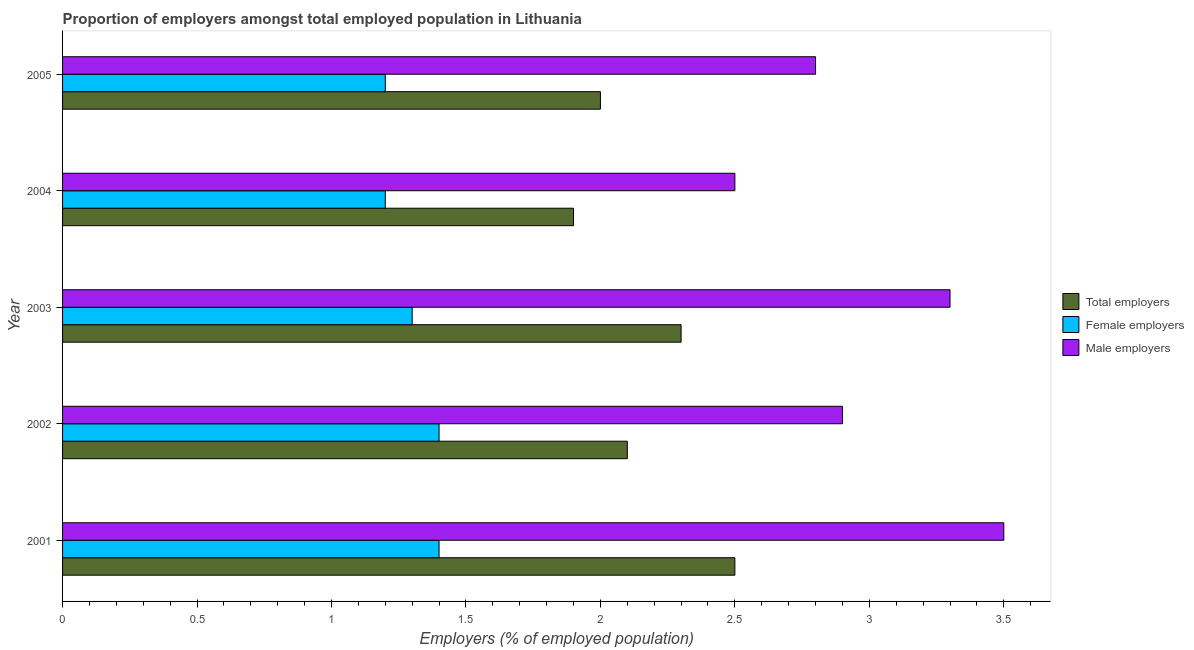How many groups of bars are there?
Offer a terse response. 5. Are the number of bars per tick equal to the number of legend labels?
Keep it short and to the point. Yes. Are the number of bars on each tick of the Y-axis equal?
Ensure brevity in your answer.  Yes. What is the label of the 3rd group of bars from the top?
Ensure brevity in your answer.  2003. In how many cases, is the number of bars for a given year not equal to the number of legend labels?
Make the answer very short. 0. What is the percentage of male employers in 2004?
Offer a terse response. 2.5. Across all years, what is the minimum percentage of total employers?
Make the answer very short. 1.9. In which year was the percentage of total employers minimum?
Give a very brief answer. 2004. What is the total percentage of male employers in the graph?
Your response must be concise. 15. What is the difference between the percentage of male employers in 2002 and the percentage of total employers in 2005?
Your response must be concise. 0.9. What is the ratio of the percentage of male employers in 2001 to that in 2005?
Ensure brevity in your answer.  1.25. Is the percentage of female employers in 2002 less than that in 2003?
Your answer should be very brief. No. Is the difference between the percentage of male employers in 2001 and 2003 greater than the difference between the percentage of total employers in 2001 and 2003?
Give a very brief answer. No. What is the difference between the highest and the second highest percentage of male employers?
Provide a short and direct response. 0.2. In how many years, is the percentage of total employers greater than the average percentage of total employers taken over all years?
Your response must be concise. 2. Is the sum of the percentage of total employers in 2001 and 2004 greater than the maximum percentage of male employers across all years?
Give a very brief answer. Yes. What does the 2nd bar from the top in 2001 represents?
Provide a succinct answer. Female employers. What does the 3rd bar from the bottom in 2001 represents?
Keep it short and to the point. Male employers. Are all the bars in the graph horizontal?
Keep it short and to the point. Yes. How many years are there in the graph?
Your response must be concise. 5. Are the values on the major ticks of X-axis written in scientific E-notation?
Offer a very short reply. No. Does the graph contain grids?
Offer a terse response. No. Where does the legend appear in the graph?
Your response must be concise. Center right. How many legend labels are there?
Your answer should be very brief. 3. How are the legend labels stacked?
Ensure brevity in your answer.  Vertical. What is the title of the graph?
Your answer should be compact. Proportion of employers amongst total employed population in Lithuania. Does "Industry" appear as one of the legend labels in the graph?
Ensure brevity in your answer.  No. What is the label or title of the X-axis?
Ensure brevity in your answer.  Employers (% of employed population). What is the Employers (% of employed population) in Total employers in 2001?
Give a very brief answer. 2.5. What is the Employers (% of employed population) in Female employers in 2001?
Make the answer very short. 1.4. What is the Employers (% of employed population) of Total employers in 2002?
Your answer should be very brief. 2.1. What is the Employers (% of employed population) in Female employers in 2002?
Give a very brief answer. 1.4. What is the Employers (% of employed population) in Male employers in 2002?
Ensure brevity in your answer.  2.9. What is the Employers (% of employed population) of Total employers in 2003?
Give a very brief answer. 2.3. What is the Employers (% of employed population) of Female employers in 2003?
Provide a short and direct response. 1.3. What is the Employers (% of employed population) of Male employers in 2003?
Your answer should be very brief. 3.3. What is the Employers (% of employed population) of Total employers in 2004?
Your answer should be very brief. 1.9. What is the Employers (% of employed population) of Female employers in 2004?
Make the answer very short. 1.2. What is the Employers (% of employed population) of Male employers in 2004?
Your answer should be compact. 2.5. What is the Employers (% of employed population) in Female employers in 2005?
Offer a very short reply. 1.2. What is the Employers (% of employed population) in Male employers in 2005?
Your answer should be very brief. 2.8. Across all years, what is the maximum Employers (% of employed population) in Total employers?
Make the answer very short. 2.5. Across all years, what is the maximum Employers (% of employed population) of Female employers?
Ensure brevity in your answer.  1.4. Across all years, what is the minimum Employers (% of employed population) of Total employers?
Make the answer very short. 1.9. Across all years, what is the minimum Employers (% of employed population) in Female employers?
Provide a succinct answer. 1.2. What is the total Employers (% of employed population) of Total employers in the graph?
Provide a succinct answer. 10.8. What is the difference between the Employers (% of employed population) of Total employers in 2001 and that in 2003?
Provide a short and direct response. 0.2. What is the difference between the Employers (% of employed population) of Male employers in 2001 and that in 2005?
Make the answer very short. 0.7. What is the difference between the Employers (% of employed population) in Total employers in 2002 and that in 2003?
Make the answer very short. -0.2. What is the difference between the Employers (% of employed population) in Male employers in 2002 and that in 2003?
Make the answer very short. -0.4. What is the difference between the Employers (% of employed population) in Female employers in 2002 and that in 2004?
Keep it short and to the point. 0.2. What is the difference between the Employers (% of employed population) in Male employers in 2002 and that in 2005?
Provide a succinct answer. 0.1. What is the difference between the Employers (% of employed population) of Total employers in 2003 and that in 2004?
Provide a succinct answer. 0.4. What is the difference between the Employers (% of employed population) in Male employers in 2003 and that in 2004?
Give a very brief answer. 0.8. What is the difference between the Employers (% of employed population) in Female employers in 2003 and that in 2005?
Provide a succinct answer. 0.1. What is the difference between the Employers (% of employed population) of Male employers in 2004 and that in 2005?
Your answer should be very brief. -0.3. What is the difference between the Employers (% of employed population) of Female employers in 2001 and the Employers (% of employed population) of Male employers in 2002?
Provide a short and direct response. -1.5. What is the difference between the Employers (% of employed population) of Total employers in 2001 and the Employers (% of employed population) of Female employers in 2003?
Offer a terse response. 1.2. What is the difference between the Employers (% of employed population) of Total employers in 2001 and the Employers (% of employed population) of Male employers in 2003?
Ensure brevity in your answer.  -0.8. What is the difference between the Employers (% of employed population) of Total employers in 2001 and the Employers (% of employed population) of Female employers in 2004?
Your response must be concise. 1.3. What is the difference between the Employers (% of employed population) in Total employers in 2001 and the Employers (% of employed population) in Male employers in 2004?
Offer a terse response. 0. What is the difference between the Employers (% of employed population) in Female employers in 2001 and the Employers (% of employed population) in Male employers in 2004?
Give a very brief answer. -1.1. What is the difference between the Employers (% of employed population) of Female employers in 2001 and the Employers (% of employed population) of Male employers in 2005?
Offer a very short reply. -1.4. What is the difference between the Employers (% of employed population) of Total employers in 2002 and the Employers (% of employed population) of Female employers in 2003?
Provide a short and direct response. 0.8. What is the difference between the Employers (% of employed population) of Total employers in 2002 and the Employers (% of employed population) of Male employers in 2004?
Offer a terse response. -0.4. What is the difference between the Employers (% of employed population) of Female employers in 2002 and the Employers (% of employed population) of Male employers in 2004?
Give a very brief answer. -1.1. What is the difference between the Employers (% of employed population) of Female employers in 2002 and the Employers (% of employed population) of Male employers in 2005?
Make the answer very short. -1.4. What is the difference between the Employers (% of employed population) of Total employers in 2003 and the Employers (% of employed population) of Female employers in 2004?
Keep it short and to the point. 1.1. What is the difference between the Employers (% of employed population) in Total employers in 2003 and the Employers (% of employed population) in Male employers in 2004?
Your response must be concise. -0.2. What is the difference between the Employers (% of employed population) in Female employers in 2003 and the Employers (% of employed population) in Male employers in 2004?
Keep it short and to the point. -1.2. What is the difference between the Employers (% of employed population) in Total employers in 2003 and the Employers (% of employed population) in Male employers in 2005?
Provide a short and direct response. -0.5. What is the difference between the Employers (% of employed population) of Total employers in 2004 and the Employers (% of employed population) of Male employers in 2005?
Give a very brief answer. -0.9. What is the difference between the Employers (% of employed population) in Female employers in 2004 and the Employers (% of employed population) in Male employers in 2005?
Your response must be concise. -1.6. What is the average Employers (% of employed population) of Total employers per year?
Your response must be concise. 2.16. In the year 2001, what is the difference between the Employers (% of employed population) in Total employers and Employers (% of employed population) in Female employers?
Make the answer very short. 1.1. In the year 2001, what is the difference between the Employers (% of employed population) of Total employers and Employers (% of employed population) of Male employers?
Provide a short and direct response. -1. In the year 2002, what is the difference between the Employers (% of employed population) of Total employers and Employers (% of employed population) of Male employers?
Provide a succinct answer. -0.8. In the year 2003, what is the difference between the Employers (% of employed population) of Total employers and Employers (% of employed population) of Female employers?
Give a very brief answer. 1. In the year 2003, what is the difference between the Employers (% of employed population) of Total employers and Employers (% of employed population) of Male employers?
Your response must be concise. -1. In the year 2003, what is the difference between the Employers (% of employed population) of Female employers and Employers (% of employed population) of Male employers?
Your answer should be compact. -2. In the year 2004, what is the difference between the Employers (% of employed population) in Total employers and Employers (% of employed population) in Female employers?
Offer a terse response. 0.7. In the year 2004, what is the difference between the Employers (% of employed population) of Female employers and Employers (% of employed population) of Male employers?
Your answer should be compact. -1.3. In the year 2005, what is the difference between the Employers (% of employed population) of Total employers and Employers (% of employed population) of Female employers?
Your answer should be very brief. 0.8. In the year 2005, what is the difference between the Employers (% of employed population) of Total employers and Employers (% of employed population) of Male employers?
Your answer should be very brief. -0.8. What is the ratio of the Employers (% of employed population) of Total employers in 2001 to that in 2002?
Your answer should be compact. 1.19. What is the ratio of the Employers (% of employed population) of Female employers in 2001 to that in 2002?
Provide a succinct answer. 1. What is the ratio of the Employers (% of employed population) in Male employers in 2001 to that in 2002?
Your answer should be very brief. 1.21. What is the ratio of the Employers (% of employed population) of Total employers in 2001 to that in 2003?
Your answer should be very brief. 1.09. What is the ratio of the Employers (% of employed population) in Female employers in 2001 to that in 2003?
Offer a very short reply. 1.08. What is the ratio of the Employers (% of employed population) of Male employers in 2001 to that in 2003?
Offer a very short reply. 1.06. What is the ratio of the Employers (% of employed population) in Total employers in 2001 to that in 2004?
Your answer should be very brief. 1.32. What is the ratio of the Employers (% of employed population) of Female employers in 2001 to that in 2004?
Make the answer very short. 1.17. What is the ratio of the Employers (% of employed population) of Male employers in 2001 to that in 2004?
Provide a succinct answer. 1.4. What is the ratio of the Employers (% of employed population) of Female employers in 2001 to that in 2005?
Make the answer very short. 1.17. What is the ratio of the Employers (% of employed population) in Total employers in 2002 to that in 2003?
Keep it short and to the point. 0.91. What is the ratio of the Employers (% of employed population) in Male employers in 2002 to that in 2003?
Offer a terse response. 0.88. What is the ratio of the Employers (% of employed population) in Total employers in 2002 to that in 2004?
Make the answer very short. 1.11. What is the ratio of the Employers (% of employed population) of Female employers in 2002 to that in 2004?
Give a very brief answer. 1.17. What is the ratio of the Employers (% of employed population) of Male employers in 2002 to that in 2004?
Your answer should be compact. 1.16. What is the ratio of the Employers (% of employed population) of Total employers in 2002 to that in 2005?
Your response must be concise. 1.05. What is the ratio of the Employers (% of employed population) of Female employers in 2002 to that in 2005?
Make the answer very short. 1.17. What is the ratio of the Employers (% of employed population) in Male employers in 2002 to that in 2005?
Make the answer very short. 1.04. What is the ratio of the Employers (% of employed population) in Total employers in 2003 to that in 2004?
Your response must be concise. 1.21. What is the ratio of the Employers (% of employed population) in Male employers in 2003 to that in 2004?
Give a very brief answer. 1.32. What is the ratio of the Employers (% of employed population) in Total employers in 2003 to that in 2005?
Offer a very short reply. 1.15. What is the ratio of the Employers (% of employed population) of Female employers in 2003 to that in 2005?
Give a very brief answer. 1.08. What is the ratio of the Employers (% of employed population) in Male employers in 2003 to that in 2005?
Your response must be concise. 1.18. What is the ratio of the Employers (% of employed population) of Female employers in 2004 to that in 2005?
Provide a short and direct response. 1. What is the ratio of the Employers (% of employed population) of Male employers in 2004 to that in 2005?
Offer a very short reply. 0.89. What is the difference between the highest and the second highest Employers (% of employed population) of Total employers?
Your answer should be very brief. 0.2. What is the difference between the highest and the second highest Employers (% of employed population) of Female employers?
Your answer should be compact. 0. What is the difference between the highest and the lowest Employers (% of employed population) in Total employers?
Ensure brevity in your answer.  0.6. What is the difference between the highest and the lowest Employers (% of employed population) in Male employers?
Provide a short and direct response. 1. 